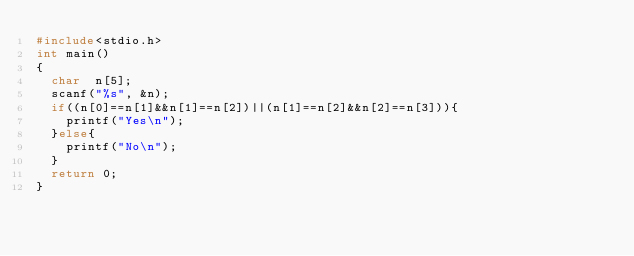<code> <loc_0><loc_0><loc_500><loc_500><_C_>#include<stdio.h>
int main()
{
  char  n[5];
  scanf("%s", &n);
  if((n[0]==n[1]&&n[1]==n[2])||(n[1]==n[2]&&n[2]==n[3])){
    printf("Yes\n");
  }else{
    printf("No\n");
  }
  return 0;
}</code> 